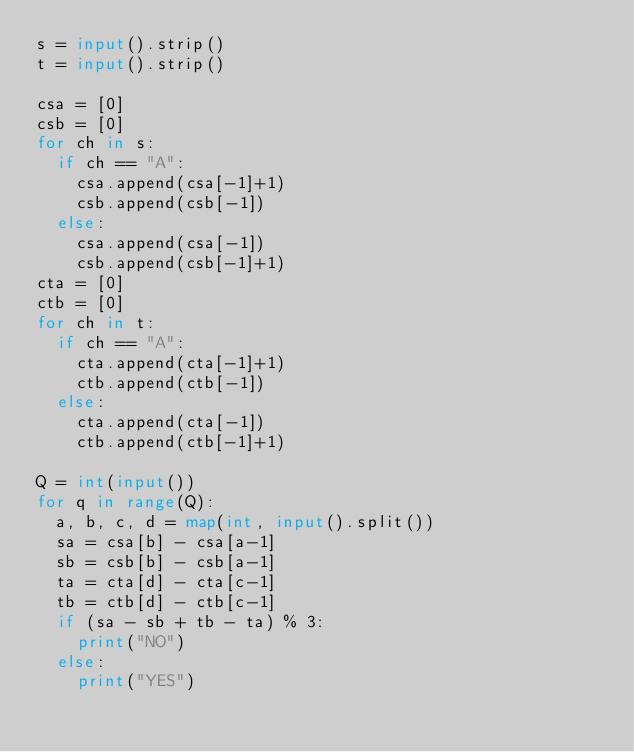<code> <loc_0><loc_0><loc_500><loc_500><_Python_>s = input().strip()
t = input().strip()

csa = [0]
csb = [0]
for ch in s:
  if ch == "A":
    csa.append(csa[-1]+1)
    csb.append(csb[-1])
  else:  
    csa.append(csa[-1])
    csb.append(csb[-1]+1)
cta = [0]
ctb = [0]
for ch in t:
  if ch == "A":
    cta.append(cta[-1]+1)
    ctb.append(ctb[-1])
  else:  
    cta.append(cta[-1])
    ctb.append(ctb[-1]+1)
    
Q = int(input())
for q in range(Q):
  a, b, c, d = map(int, input().split())
  sa = csa[b] - csa[a-1]
  sb = csb[b] - csb[a-1]
  ta = cta[d] - cta[c-1]
  tb = ctb[d] - ctb[c-1]
  if (sa - sb + tb - ta) % 3:
    print("NO")
  else:  
    print("YES")
</code> 